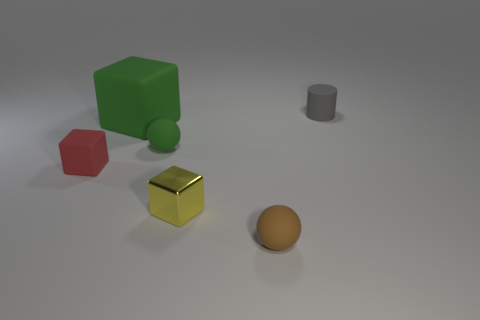Is the number of small rubber cylinders greater than the number of purple cubes?
Keep it short and to the point. Yes. What number of other objects have the same size as the red object?
Provide a short and direct response. 4. Is the brown object made of the same material as the tiny block that is on the left side of the large cube?
Offer a very short reply. Yes. Is the number of green blocks less than the number of balls?
Your answer should be very brief. Yes. Is there anything else that has the same color as the metal block?
Provide a succinct answer. No. There is a tiny red thing that is the same material as the green ball; what shape is it?
Make the answer very short. Cube. What number of things are in front of the small ball in front of the small block that is on the right side of the small red matte thing?
Your answer should be very brief. 0. There is a small matte object that is on the right side of the yellow shiny cube and behind the tiny yellow thing; what is its shape?
Make the answer very short. Cylinder. Is the number of red matte things right of the small yellow thing less than the number of yellow cubes?
Ensure brevity in your answer.  Yes. What number of small objects are brown metal things or yellow objects?
Your answer should be very brief. 1. 